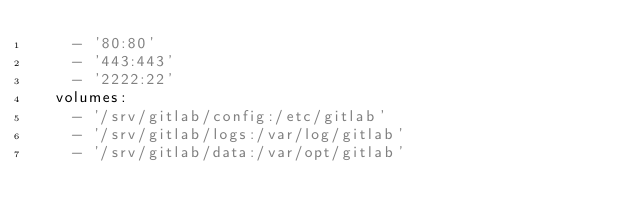<code> <loc_0><loc_0><loc_500><loc_500><_YAML_>    - '80:80'
    - '443:443'
    - '2222:22'
  volumes:
    - '/srv/gitlab/config:/etc/gitlab'
    - '/srv/gitlab/logs:/var/log/gitlab'
    - '/srv/gitlab/data:/var/opt/gitlab'
</code> 